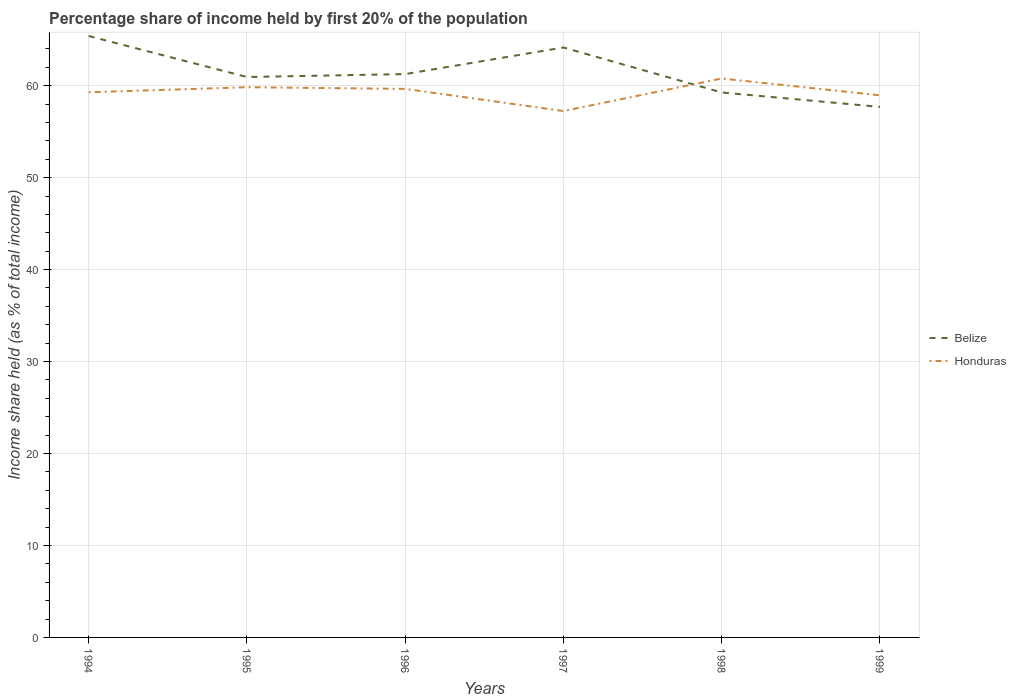How many different coloured lines are there?
Provide a short and direct response. 2. Does the line corresponding to Belize intersect with the line corresponding to Honduras?
Offer a terse response. Yes. Is the number of lines equal to the number of legend labels?
Provide a short and direct response. Yes. Across all years, what is the maximum share of income held by first 20% of the population in Belize?
Offer a terse response. 57.69. What is the total share of income held by first 20% of the population in Belize in the graph?
Offer a very short reply. 1.57. What is the difference between the highest and the second highest share of income held by first 20% of the population in Belize?
Offer a terse response. 7.71. Is the share of income held by first 20% of the population in Belize strictly greater than the share of income held by first 20% of the population in Honduras over the years?
Provide a short and direct response. No. How many lines are there?
Make the answer very short. 2. How many years are there in the graph?
Your response must be concise. 6. What is the difference between two consecutive major ticks on the Y-axis?
Keep it short and to the point. 10. Does the graph contain any zero values?
Your response must be concise. No. How are the legend labels stacked?
Ensure brevity in your answer.  Vertical. What is the title of the graph?
Provide a succinct answer. Percentage share of income held by first 20% of the population. Does "Niger" appear as one of the legend labels in the graph?
Provide a short and direct response. No. What is the label or title of the Y-axis?
Your answer should be very brief. Income share held (as % of total income). What is the Income share held (as % of total income) of Belize in 1994?
Your answer should be compact. 65.4. What is the Income share held (as % of total income) in Honduras in 1994?
Keep it short and to the point. 59.28. What is the Income share held (as % of total income) in Belize in 1995?
Your answer should be compact. 60.94. What is the Income share held (as % of total income) in Honduras in 1995?
Provide a succinct answer. 59.83. What is the Income share held (as % of total income) in Belize in 1996?
Provide a short and direct response. 61.26. What is the Income share held (as % of total income) in Honduras in 1996?
Make the answer very short. 59.65. What is the Income share held (as % of total income) in Belize in 1997?
Your answer should be very brief. 64.15. What is the Income share held (as % of total income) in Honduras in 1997?
Provide a succinct answer. 57.24. What is the Income share held (as % of total income) of Belize in 1998?
Make the answer very short. 59.26. What is the Income share held (as % of total income) in Honduras in 1998?
Provide a succinct answer. 60.78. What is the Income share held (as % of total income) of Belize in 1999?
Provide a succinct answer. 57.69. What is the Income share held (as % of total income) in Honduras in 1999?
Your answer should be very brief. 58.95. Across all years, what is the maximum Income share held (as % of total income) of Belize?
Make the answer very short. 65.4. Across all years, what is the maximum Income share held (as % of total income) of Honduras?
Give a very brief answer. 60.78. Across all years, what is the minimum Income share held (as % of total income) of Belize?
Keep it short and to the point. 57.69. Across all years, what is the minimum Income share held (as % of total income) in Honduras?
Your answer should be compact. 57.24. What is the total Income share held (as % of total income) in Belize in the graph?
Keep it short and to the point. 368.7. What is the total Income share held (as % of total income) of Honduras in the graph?
Provide a succinct answer. 355.73. What is the difference between the Income share held (as % of total income) in Belize in 1994 and that in 1995?
Provide a short and direct response. 4.46. What is the difference between the Income share held (as % of total income) of Honduras in 1994 and that in 1995?
Keep it short and to the point. -0.55. What is the difference between the Income share held (as % of total income) in Belize in 1994 and that in 1996?
Your answer should be very brief. 4.14. What is the difference between the Income share held (as % of total income) in Honduras in 1994 and that in 1996?
Provide a short and direct response. -0.37. What is the difference between the Income share held (as % of total income) in Belize in 1994 and that in 1997?
Provide a succinct answer. 1.25. What is the difference between the Income share held (as % of total income) in Honduras in 1994 and that in 1997?
Ensure brevity in your answer.  2.04. What is the difference between the Income share held (as % of total income) in Belize in 1994 and that in 1998?
Your answer should be compact. 6.14. What is the difference between the Income share held (as % of total income) in Honduras in 1994 and that in 1998?
Offer a terse response. -1.5. What is the difference between the Income share held (as % of total income) in Belize in 1994 and that in 1999?
Make the answer very short. 7.71. What is the difference between the Income share held (as % of total income) of Honduras in 1994 and that in 1999?
Provide a succinct answer. 0.33. What is the difference between the Income share held (as % of total income) of Belize in 1995 and that in 1996?
Your answer should be compact. -0.32. What is the difference between the Income share held (as % of total income) of Honduras in 1995 and that in 1996?
Ensure brevity in your answer.  0.18. What is the difference between the Income share held (as % of total income) of Belize in 1995 and that in 1997?
Your answer should be very brief. -3.21. What is the difference between the Income share held (as % of total income) in Honduras in 1995 and that in 1997?
Your answer should be very brief. 2.59. What is the difference between the Income share held (as % of total income) of Belize in 1995 and that in 1998?
Your response must be concise. 1.68. What is the difference between the Income share held (as % of total income) of Honduras in 1995 and that in 1998?
Make the answer very short. -0.95. What is the difference between the Income share held (as % of total income) in Belize in 1995 and that in 1999?
Your response must be concise. 3.25. What is the difference between the Income share held (as % of total income) in Belize in 1996 and that in 1997?
Offer a terse response. -2.89. What is the difference between the Income share held (as % of total income) in Honduras in 1996 and that in 1997?
Provide a succinct answer. 2.41. What is the difference between the Income share held (as % of total income) of Honduras in 1996 and that in 1998?
Ensure brevity in your answer.  -1.13. What is the difference between the Income share held (as % of total income) of Belize in 1996 and that in 1999?
Provide a succinct answer. 3.57. What is the difference between the Income share held (as % of total income) of Belize in 1997 and that in 1998?
Provide a succinct answer. 4.89. What is the difference between the Income share held (as % of total income) in Honduras in 1997 and that in 1998?
Offer a very short reply. -3.54. What is the difference between the Income share held (as % of total income) of Belize in 1997 and that in 1999?
Give a very brief answer. 6.46. What is the difference between the Income share held (as % of total income) in Honduras in 1997 and that in 1999?
Offer a very short reply. -1.71. What is the difference between the Income share held (as % of total income) of Belize in 1998 and that in 1999?
Ensure brevity in your answer.  1.57. What is the difference between the Income share held (as % of total income) in Honduras in 1998 and that in 1999?
Provide a short and direct response. 1.83. What is the difference between the Income share held (as % of total income) in Belize in 1994 and the Income share held (as % of total income) in Honduras in 1995?
Your answer should be very brief. 5.57. What is the difference between the Income share held (as % of total income) in Belize in 1994 and the Income share held (as % of total income) in Honduras in 1996?
Offer a very short reply. 5.75. What is the difference between the Income share held (as % of total income) in Belize in 1994 and the Income share held (as % of total income) in Honduras in 1997?
Your response must be concise. 8.16. What is the difference between the Income share held (as % of total income) in Belize in 1994 and the Income share held (as % of total income) in Honduras in 1998?
Provide a short and direct response. 4.62. What is the difference between the Income share held (as % of total income) in Belize in 1994 and the Income share held (as % of total income) in Honduras in 1999?
Keep it short and to the point. 6.45. What is the difference between the Income share held (as % of total income) of Belize in 1995 and the Income share held (as % of total income) of Honduras in 1996?
Make the answer very short. 1.29. What is the difference between the Income share held (as % of total income) in Belize in 1995 and the Income share held (as % of total income) in Honduras in 1998?
Provide a short and direct response. 0.16. What is the difference between the Income share held (as % of total income) in Belize in 1995 and the Income share held (as % of total income) in Honduras in 1999?
Ensure brevity in your answer.  1.99. What is the difference between the Income share held (as % of total income) in Belize in 1996 and the Income share held (as % of total income) in Honduras in 1997?
Give a very brief answer. 4.02. What is the difference between the Income share held (as % of total income) of Belize in 1996 and the Income share held (as % of total income) of Honduras in 1998?
Your response must be concise. 0.48. What is the difference between the Income share held (as % of total income) of Belize in 1996 and the Income share held (as % of total income) of Honduras in 1999?
Your answer should be compact. 2.31. What is the difference between the Income share held (as % of total income) in Belize in 1997 and the Income share held (as % of total income) in Honduras in 1998?
Keep it short and to the point. 3.37. What is the difference between the Income share held (as % of total income) in Belize in 1998 and the Income share held (as % of total income) in Honduras in 1999?
Your response must be concise. 0.31. What is the average Income share held (as % of total income) in Belize per year?
Provide a short and direct response. 61.45. What is the average Income share held (as % of total income) in Honduras per year?
Your answer should be very brief. 59.29. In the year 1994, what is the difference between the Income share held (as % of total income) of Belize and Income share held (as % of total income) of Honduras?
Provide a succinct answer. 6.12. In the year 1995, what is the difference between the Income share held (as % of total income) of Belize and Income share held (as % of total income) of Honduras?
Your answer should be compact. 1.11. In the year 1996, what is the difference between the Income share held (as % of total income) in Belize and Income share held (as % of total income) in Honduras?
Your answer should be very brief. 1.61. In the year 1997, what is the difference between the Income share held (as % of total income) in Belize and Income share held (as % of total income) in Honduras?
Your answer should be very brief. 6.91. In the year 1998, what is the difference between the Income share held (as % of total income) of Belize and Income share held (as % of total income) of Honduras?
Your answer should be compact. -1.52. In the year 1999, what is the difference between the Income share held (as % of total income) in Belize and Income share held (as % of total income) in Honduras?
Your answer should be compact. -1.26. What is the ratio of the Income share held (as % of total income) in Belize in 1994 to that in 1995?
Give a very brief answer. 1.07. What is the ratio of the Income share held (as % of total income) in Belize in 1994 to that in 1996?
Keep it short and to the point. 1.07. What is the ratio of the Income share held (as % of total income) in Honduras in 1994 to that in 1996?
Your response must be concise. 0.99. What is the ratio of the Income share held (as % of total income) of Belize in 1994 to that in 1997?
Make the answer very short. 1.02. What is the ratio of the Income share held (as % of total income) in Honduras in 1994 to that in 1997?
Make the answer very short. 1.04. What is the ratio of the Income share held (as % of total income) in Belize in 1994 to that in 1998?
Your answer should be compact. 1.1. What is the ratio of the Income share held (as % of total income) of Honduras in 1994 to that in 1998?
Provide a succinct answer. 0.98. What is the ratio of the Income share held (as % of total income) in Belize in 1994 to that in 1999?
Offer a very short reply. 1.13. What is the ratio of the Income share held (as % of total income) in Honduras in 1994 to that in 1999?
Make the answer very short. 1.01. What is the ratio of the Income share held (as % of total income) in Belize in 1995 to that in 1996?
Make the answer very short. 0.99. What is the ratio of the Income share held (as % of total income) of Honduras in 1995 to that in 1997?
Make the answer very short. 1.05. What is the ratio of the Income share held (as % of total income) in Belize in 1995 to that in 1998?
Make the answer very short. 1.03. What is the ratio of the Income share held (as % of total income) in Honduras in 1995 to that in 1998?
Ensure brevity in your answer.  0.98. What is the ratio of the Income share held (as % of total income) in Belize in 1995 to that in 1999?
Provide a succinct answer. 1.06. What is the ratio of the Income share held (as % of total income) in Honduras in 1995 to that in 1999?
Provide a short and direct response. 1.01. What is the ratio of the Income share held (as % of total income) in Belize in 1996 to that in 1997?
Your answer should be very brief. 0.95. What is the ratio of the Income share held (as % of total income) in Honduras in 1996 to that in 1997?
Keep it short and to the point. 1.04. What is the ratio of the Income share held (as % of total income) of Belize in 1996 to that in 1998?
Offer a terse response. 1.03. What is the ratio of the Income share held (as % of total income) of Honduras in 1996 to that in 1998?
Provide a short and direct response. 0.98. What is the ratio of the Income share held (as % of total income) of Belize in 1996 to that in 1999?
Ensure brevity in your answer.  1.06. What is the ratio of the Income share held (as % of total income) in Honduras in 1996 to that in 1999?
Give a very brief answer. 1.01. What is the ratio of the Income share held (as % of total income) in Belize in 1997 to that in 1998?
Make the answer very short. 1.08. What is the ratio of the Income share held (as % of total income) of Honduras in 1997 to that in 1998?
Your answer should be very brief. 0.94. What is the ratio of the Income share held (as % of total income) in Belize in 1997 to that in 1999?
Give a very brief answer. 1.11. What is the ratio of the Income share held (as % of total income) of Belize in 1998 to that in 1999?
Make the answer very short. 1.03. What is the ratio of the Income share held (as % of total income) in Honduras in 1998 to that in 1999?
Ensure brevity in your answer.  1.03. What is the difference between the highest and the second highest Income share held (as % of total income) in Honduras?
Offer a very short reply. 0.95. What is the difference between the highest and the lowest Income share held (as % of total income) of Belize?
Your response must be concise. 7.71. What is the difference between the highest and the lowest Income share held (as % of total income) of Honduras?
Offer a very short reply. 3.54. 